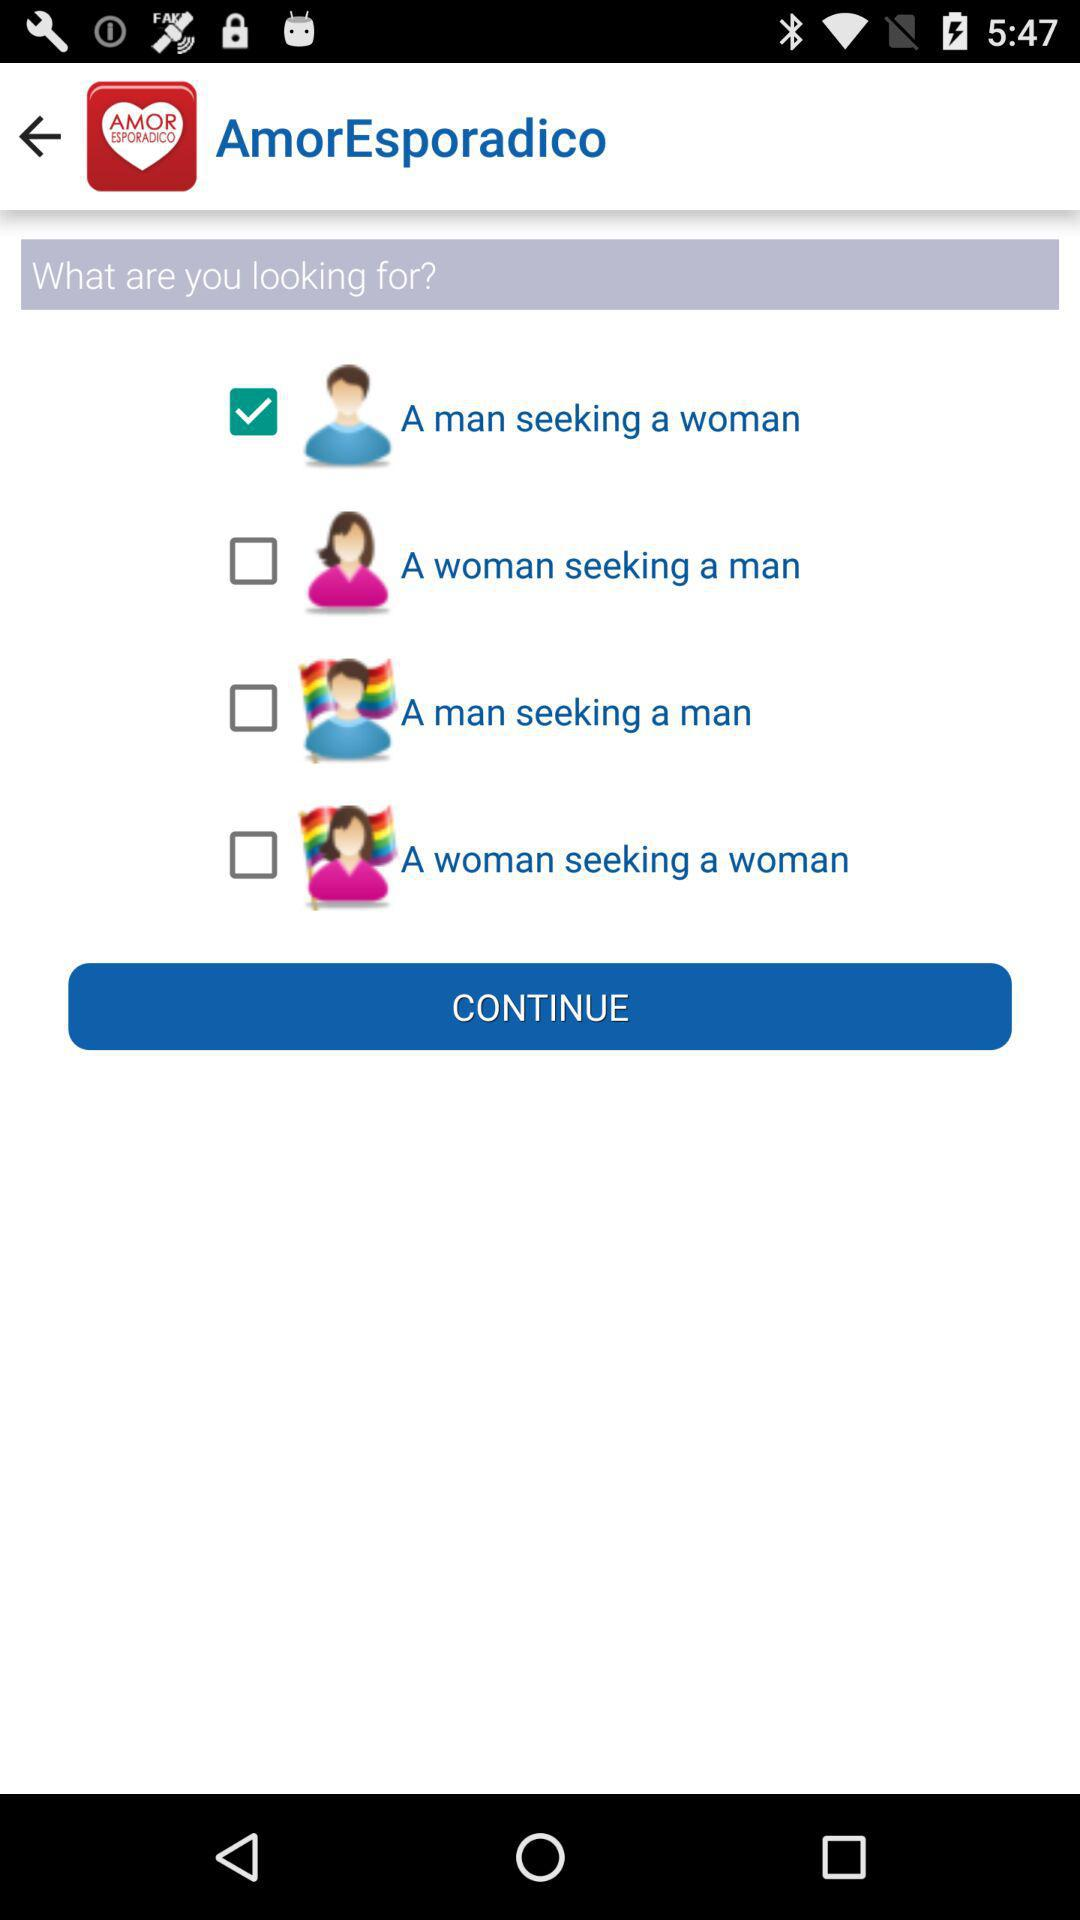How many more checkboxes are there for men than women?
Answer the question using a single word or phrase. 1 